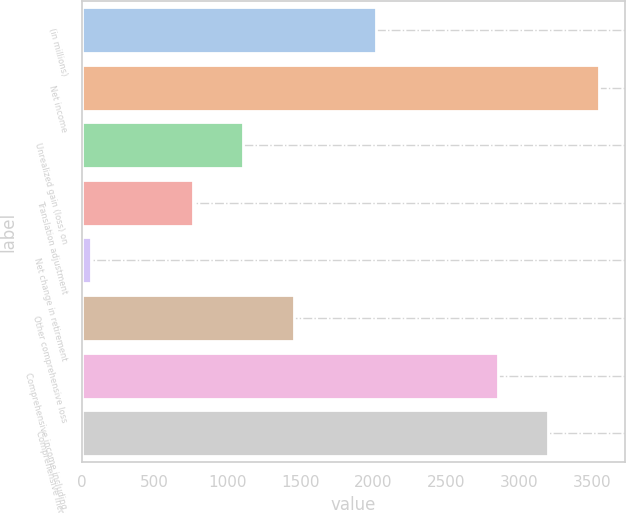Convert chart to OTSL. <chart><loc_0><loc_0><loc_500><loc_500><bar_chart><fcel>(in millions)<fcel>Net income<fcel>Unrealized gain (loss) on<fcel>Translation adjustment<fcel>Net change in retirement<fcel>Other comprehensive loss<fcel>Comprehensive income including<fcel>Comprehensive income<nl><fcel>2016<fcel>3548.4<fcel>1107.6<fcel>760.4<fcel>66<fcel>1454.8<fcel>2854<fcel>3201.2<nl></chart> 